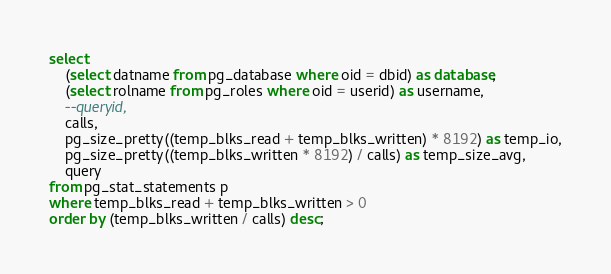Convert code to text. <code><loc_0><loc_0><loc_500><loc_500><_SQL_>select
    (select datname from pg_database where oid = dbid) as database,
    (select rolname from pg_roles where oid = userid) as username,
    --queryid,
    calls,
    pg_size_pretty((temp_blks_read + temp_blks_written) * 8192) as temp_io,
    pg_size_pretty((temp_blks_written * 8192) / calls) as temp_size_avg,
    query
from pg_stat_statements p
where temp_blks_read + temp_blks_written > 0
order by (temp_blks_written / calls) desc;
</code> 